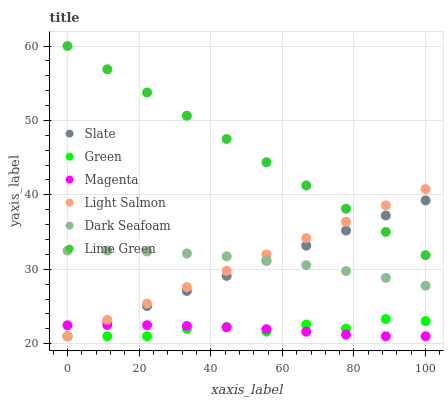Does Magenta have the minimum area under the curve?
Answer yes or no. Yes. Does Lime Green have the maximum area under the curve?
Answer yes or no. Yes. Does Slate have the minimum area under the curve?
Answer yes or no. No. Does Slate have the maximum area under the curve?
Answer yes or no. No. Is Slate the smoothest?
Answer yes or no. Yes. Is Green the roughest?
Answer yes or no. Yes. Is Dark Seafoam the smoothest?
Answer yes or no. No. Is Dark Seafoam the roughest?
Answer yes or no. No. Does Light Salmon have the lowest value?
Answer yes or no. Yes. Does Dark Seafoam have the lowest value?
Answer yes or no. No. Does Lime Green have the highest value?
Answer yes or no. Yes. Does Slate have the highest value?
Answer yes or no. No. Is Magenta less than Dark Seafoam?
Answer yes or no. Yes. Is Lime Green greater than Dark Seafoam?
Answer yes or no. Yes. Does Green intersect Light Salmon?
Answer yes or no. Yes. Is Green less than Light Salmon?
Answer yes or no. No. Is Green greater than Light Salmon?
Answer yes or no. No. Does Magenta intersect Dark Seafoam?
Answer yes or no. No. 